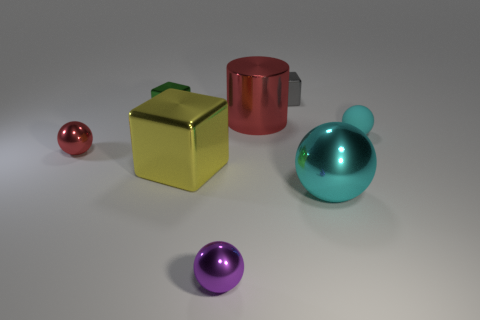Is the number of blue balls greater than the number of large objects?
Keep it short and to the point. No. What is the size of the object that is both in front of the green object and behind the small cyan rubber object?
Give a very brief answer. Large. What is the shape of the small purple thing?
Make the answer very short. Sphere. How many other cyan objects are the same shape as the large cyan object?
Your answer should be very brief. 1. Is the number of gray shiny things that are on the left side of the green metallic block less than the number of small things that are on the left side of the big red shiny thing?
Provide a succinct answer. Yes. What number of cyan metallic objects are to the left of the sphere in front of the large metal sphere?
Provide a short and direct response. 0. Are any big red rubber objects visible?
Ensure brevity in your answer.  No. Are there any other tiny blocks that have the same material as the gray cube?
Make the answer very short. Yes. Is the number of cyan balls that are in front of the green metal thing greater than the number of red cylinders that are in front of the large yellow block?
Ensure brevity in your answer.  Yes. Is the cylinder the same size as the gray block?
Provide a succinct answer. No. 